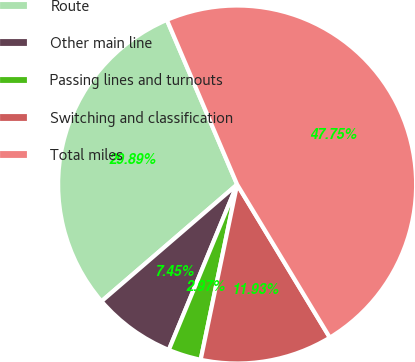Convert chart. <chart><loc_0><loc_0><loc_500><loc_500><pie_chart><fcel>Route<fcel>Other main line<fcel>Passing lines and turnouts<fcel>Switching and classification<fcel>Total miles<nl><fcel>29.89%<fcel>7.45%<fcel>2.97%<fcel>11.93%<fcel>47.75%<nl></chart> 